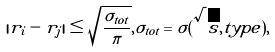<formula> <loc_0><loc_0><loc_500><loc_500>| r _ { i } - r _ { j } | \leq \sqrt { \frac { \sigma _ { t o t } } { \pi } } , \sigma _ { t o t } = \sigma ( \sqrt { s } , t y p e ) ,</formula> 